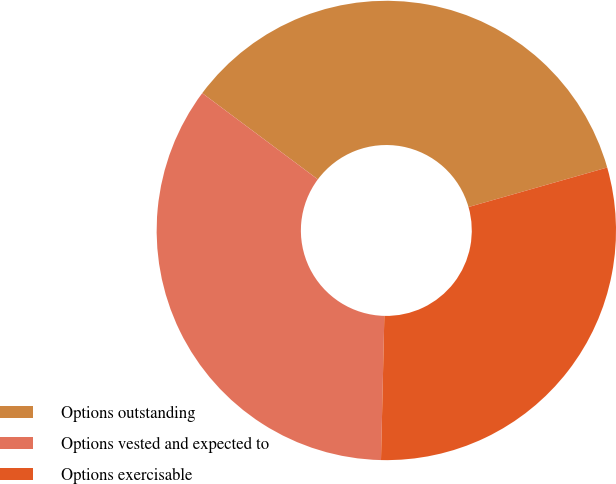Convert chart to OTSL. <chart><loc_0><loc_0><loc_500><loc_500><pie_chart><fcel>Options outstanding<fcel>Options vested and expected to<fcel>Options exercisable<nl><fcel>35.38%<fcel>34.83%<fcel>29.79%<nl></chart> 